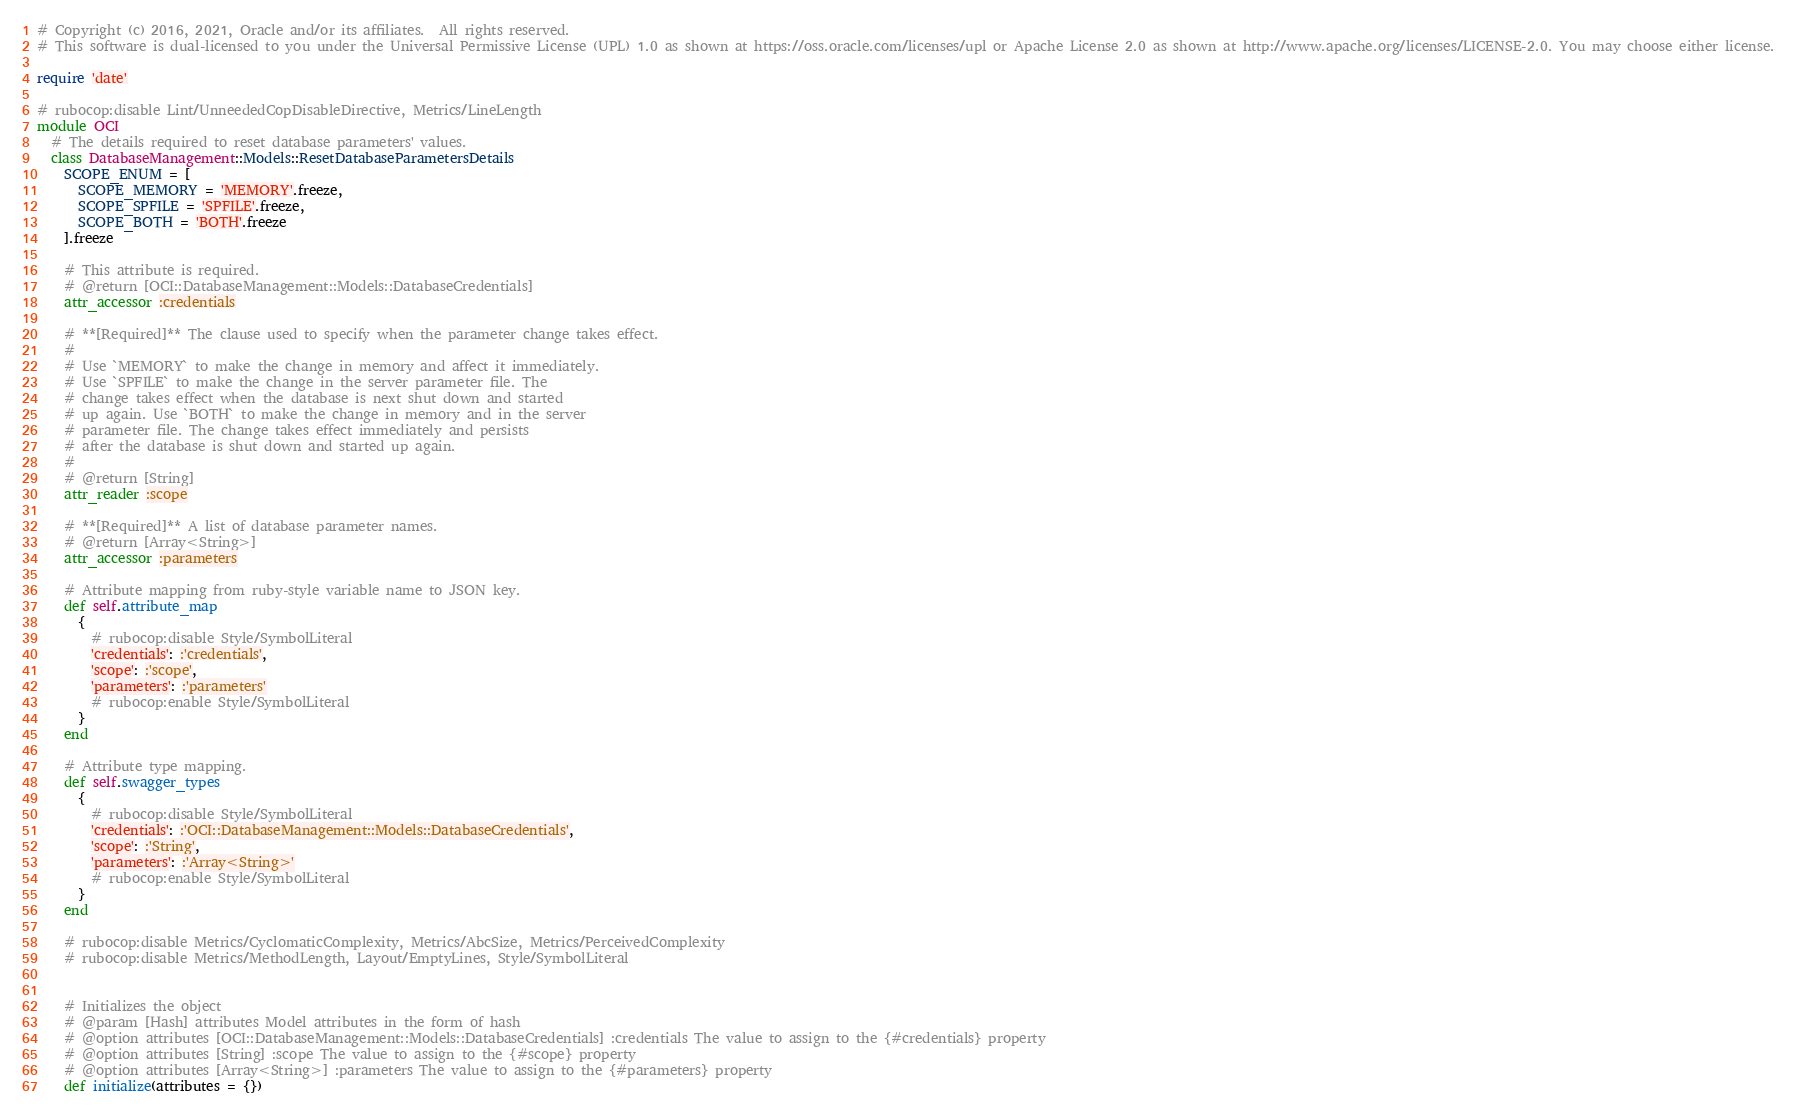Convert code to text. <code><loc_0><loc_0><loc_500><loc_500><_Ruby_># Copyright (c) 2016, 2021, Oracle and/or its affiliates.  All rights reserved.
# This software is dual-licensed to you under the Universal Permissive License (UPL) 1.0 as shown at https://oss.oracle.com/licenses/upl or Apache License 2.0 as shown at http://www.apache.org/licenses/LICENSE-2.0. You may choose either license.

require 'date'

# rubocop:disable Lint/UnneededCopDisableDirective, Metrics/LineLength
module OCI
  # The details required to reset database parameters' values.
  class DatabaseManagement::Models::ResetDatabaseParametersDetails
    SCOPE_ENUM = [
      SCOPE_MEMORY = 'MEMORY'.freeze,
      SCOPE_SPFILE = 'SPFILE'.freeze,
      SCOPE_BOTH = 'BOTH'.freeze
    ].freeze

    # This attribute is required.
    # @return [OCI::DatabaseManagement::Models::DatabaseCredentials]
    attr_accessor :credentials

    # **[Required]** The clause used to specify when the parameter change takes effect.
    #
    # Use `MEMORY` to make the change in memory and affect it immediately.
    # Use `SPFILE` to make the change in the server parameter file. The
    # change takes effect when the database is next shut down and started
    # up again. Use `BOTH` to make the change in memory and in the server
    # parameter file. The change takes effect immediately and persists
    # after the database is shut down and started up again.
    #
    # @return [String]
    attr_reader :scope

    # **[Required]** A list of database parameter names.
    # @return [Array<String>]
    attr_accessor :parameters

    # Attribute mapping from ruby-style variable name to JSON key.
    def self.attribute_map
      {
        # rubocop:disable Style/SymbolLiteral
        'credentials': :'credentials',
        'scope': :'scope',
        'parameters': :'parameters'
        # rubocop:enable Style/SymbolLiteral
      }
    end

    # Attribute type mapping.
    def self.swagger_types
      {
        # rubocop:disable Style/SymbolLiteral
        'credentials': :'OCI::DatabaseManagement::Models::DatabaseCredentials',
        'scope': :'String',
        'parameters': :'Array<String>'
        # rubocop:enable Style/SymbolLiteral
      }
    end

    # rubocop:disable Metrics/CyclomaticComplexity, Metrics/AbcSize, Metrics/PerceivedComplexity
    # rubocop:disable Metrics/MethodLength, Layout/EmptyLines, Style/SymbolLiteral


    # Initializes the object
    # @param [Hash] attributes Model attributes in the form of hash
    # @option attributes [OCI::DatabaseManagement::Models::DatabaseCredentials] :credentials The value to assign to the {#credentials} property
    # @option attributes [String] :scope The value to assign to the {#scope} property
    # @option attributes [Array<String>] :parameters The value to assign to the {#parameters} property
    def initialize(attributes = {})</code> 